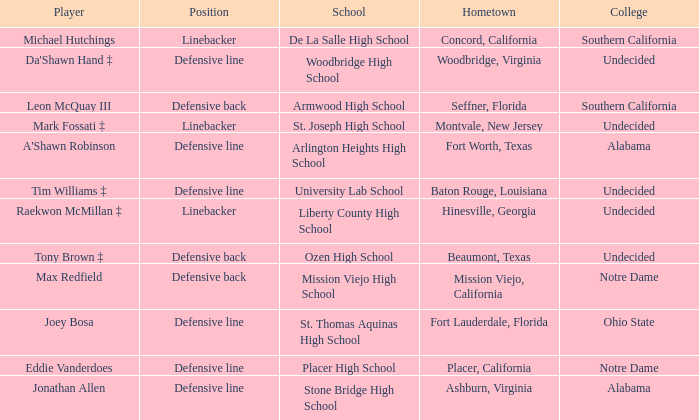What is the position of the player from Beaumont, Texas? Defensive back. 